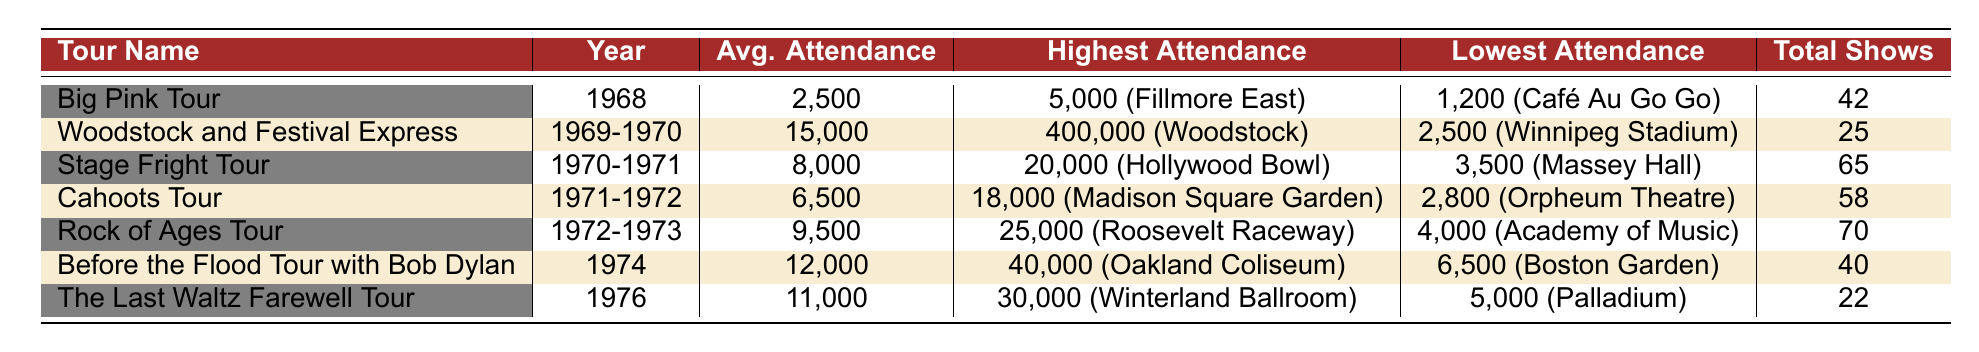What was the highest attendance recorded for the Woodstock and Festival Express? According to the table, the highest attendance for the Woodstock and Festival Express was 400,000 at Woodstock.
Answer: 400,000 Which tour had the lowest average attendance? By reviewing the Average Attendance column, the Big Pink Tour had the lowest average attendance of 2,500.
Answer: 2,500 What is the difference in average attendance between the Rock of Ages Tour and the Stage Fright Tour? The average attendance for the Rock of Ages Tour is 9,500, and for the Stage Fright Tour, it is 8,000. The difference is 9,500 - 8,000 = 1,500.
Answer: 1,500 Did The Band perform more total shows during the Stage Fright Tour or the Cahoots Tour? The Stage Fright Tour had 65 shows and the Cahoots Tour had 58 shows. Thus, the Stage Fright Tour had more total shows.
Answer: Yes What was the average attendance across all tours listed? To calculate the average attendance: (2500 + 15000 + 8000 + 6500 + 9500 + 12000 + 11000) = 57000. There are 7 tours, so the average is 57000 / 7 = 8,142.86.
Answer: 8,142.86 Which tour had the highest recorded attendance and what was that attendance? The Woodstock and Festival Express had the highest recorded attendance of 400,000.
Answer: 400,000 What year did the Before the Flood Tour occur? Referring to the Year column, the Before the Flood Tour occurred in 1974.
Answer: 1974 Which tour had the smallest difference between its highest and lowest attendance? Looking at the differences: Big Pink Tour (3,800), Woodstock and Festival Express (397,500), Stage Fright Tour (16,500), Cahoots Tour (15,200), Rock of Ages Tour (21,000), Before the Flood Tour (33,500), The Last Waltz Farewell Tour (25,000). The Big Pink Tour had the smallest difference of 3,800.
Answer: Big Pink Tour What percentage of the total shows during the Cahoots Tour compared to the total shows of all tours? The Cahoots Tour had 58 shows. The total number of shows across all tours is 42 + 25 + 65 + 58 + 70 + 40 + 22 = 322. The percentage is (58 / 322) * 100 ≈ 18.01%.
Answer: 18.01% Which tour had an average attendance above 10,000? By examining the Average Attendance column, the tours with an average attendance above 10,000 are Woodstock and Festival Express (15,000) and Before the Flood Tour (12,000).
Answer: Woodstock and Festival Express, Before the Flood Tour 